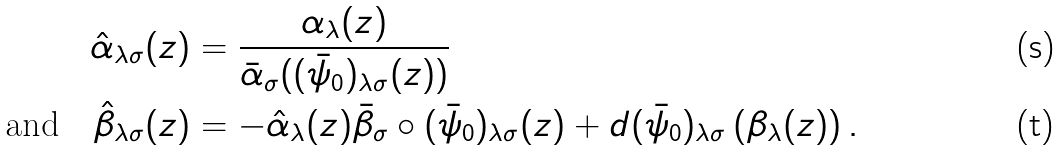<formula> <loc_0><loc_0><loc_500><loc_500>\hat { \alpha } _ { \lambda \sigma } ( z ) & = \frac { \alpha _ { \lambda } ( z ) } { \bar { \alpha } _ { \sigma } ( ( \bar { \psi } _ { 0 } ) _ { \lambda \sigma } ( z ) ) } \\ \text {and} \quad \hat { \beta } _ { \lambda \sigma } ( z ) & = - \hat { \alpha } _ { \lambda } ( z ) \bar { \beta } _ { \sigma } \circ ( \bar { \psi } _ { 0 } ) _ { \lambda \sigma } ( z ) + d ( \bar { \psi } _ { 0 } ) _ { \lambda \sigma } \left ( \beta _ { \lambda } ( z ) \right ) .</formula> 